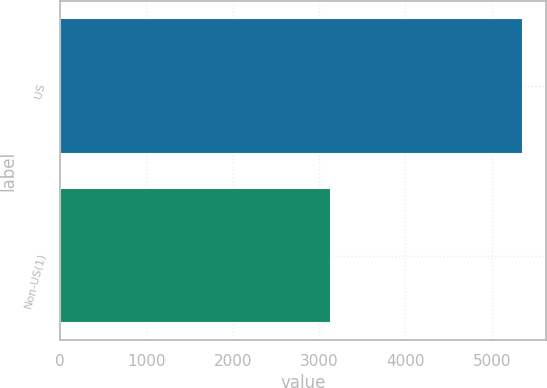<chart> <loc_0><loc_0><loc_500><loc_500><bar_chart><fcel>US<fcel>Non-US(1)<nl><fcel>5360<fcel>3135<nl></chart> 